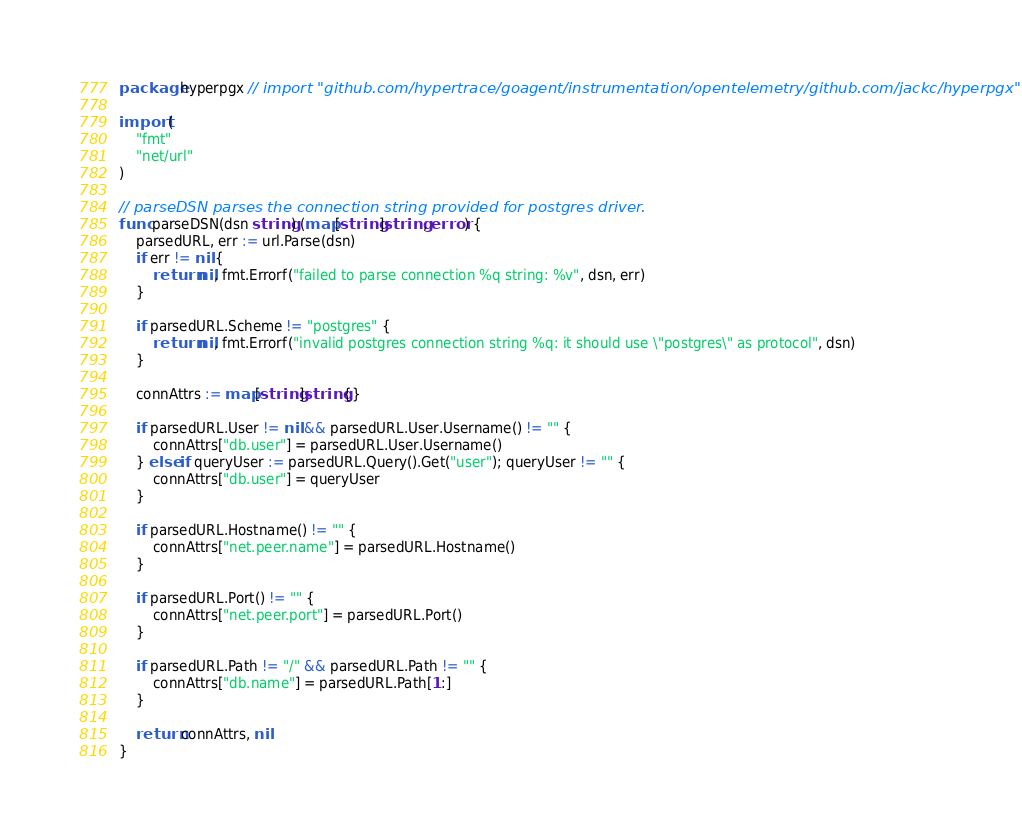<code> <loc_0><loc_0><loc_500><loc_500><_Go_>package hyperpgx // import "github.com/hypertrace/goagent/instrumentation/opentelemetry/github.com/jackc/hyperpgx"

import (
	"fmt"
	"net/url"
)

// parseDSN parses the connection string provided for postgres driver.
func parseDSN(dsn string) (map[string]string, error) {
	parsedURL, err := url.Parse(dsn)
	if err != nil {
		return nil, fmt.Errorf("failed to parse connection %q string: %v", dsn, err)
	}

	if parsedURL.Scheme != "postgres" {
		return nil, fmt.Errorf("invalid postgres connection string %q: it should use \"postgres\" as protocol", dsn)
	}

	connAttrs := map[string]string{}

	if parsedURL.User != nil && parsedURL.User.Username() != "" {
		connAttrs["db.user"] = parsedURL.User.Username()
	} else if queryUser := parsedURL.Query().Get("user"); queryUser != "" {
		connAttrs["db.user"] = queryUser
	}

	if parsedURL.Hostname() != "" {
		connAttrs["net.peer.name"] = parsedURL.Hostname()
	}

	if parsedURL.Port() != "" {
		connAttrs["net.peer.port"] = parsedURL.Port()
	}

	if parsedURL.Path != "/" && parsedURL.Path != "" {
		connAttrs["db.name"] = parsedURL.Path[1:]
	}

	return connAttrs, nil
}
</code> 